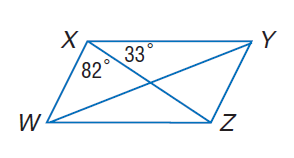Answer the mathemtical geometry problem and directly provide the correct option letter.
Question: W X Y Z is a parallelogram. Find m \angle X W Z.
Choices: A: 33 B: 65 C: 82 D: 115 B 